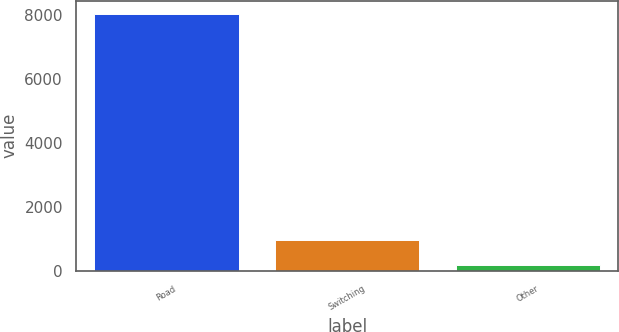<chart> <loc_0><loc_0><loc_500><loc_500><bar_chart><fcel>Road<fcel>Switching<fcel>Other<nl><fcel>8034<fcel>953.7<fcel>167<nl></chart> 